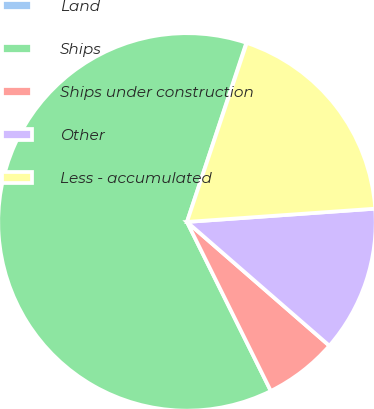Convert chart to OTSL. <chart><loc_0><loc_0><loc_500><loc_500><pie_chart><fcel>Land<fcel>Ships<fcel>Ships under construction<fcel>Other<fcel>Less - accumulated<nl><fcel>0.04%<fcel>62.42%<fcel>6.28%<fcel>12.51%<fcel>18.75%<nl></chart> 